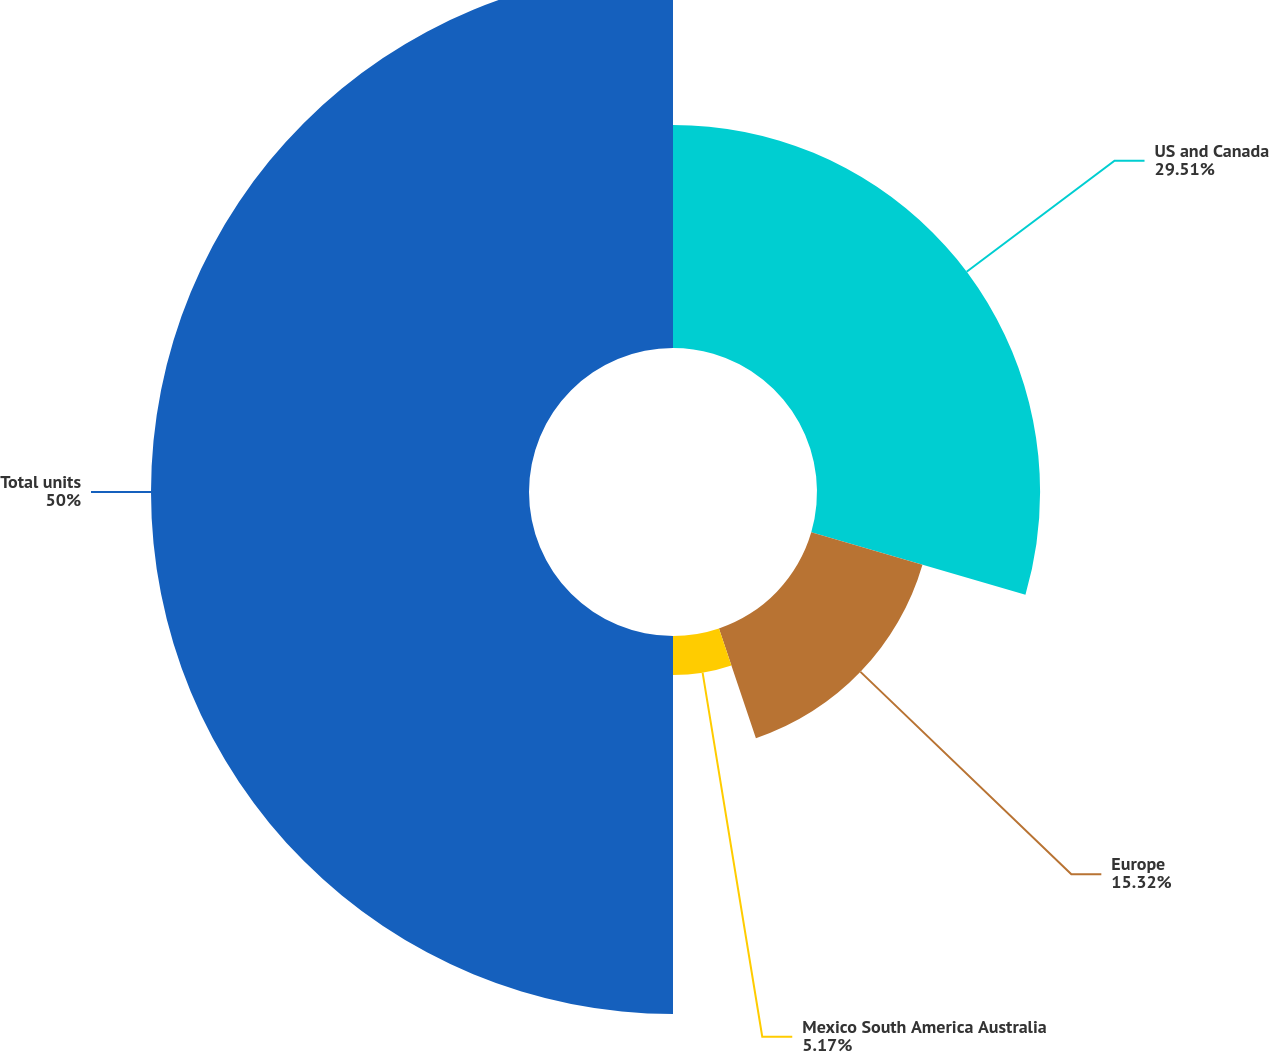<chart> <loc_0><loc_0><loc_500><loc_500><pie_chart><fcel>US and Canada<fcel>Europe<fcel>Mexico South America Australia<fcel>Total units<nl><fcel>29.51%<fcel>15.32%<fcel>5.17%<fcel>50.0%<nl></chart> 